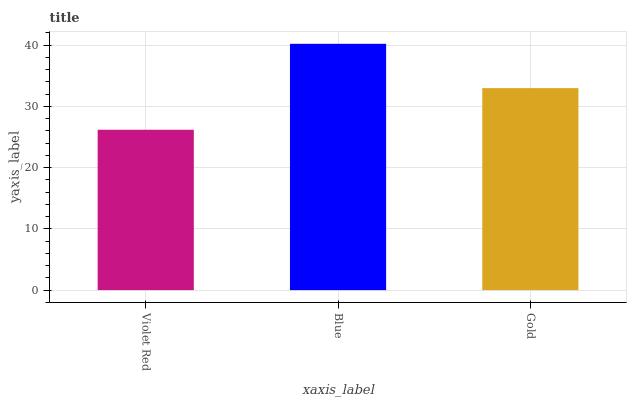Is Violet Red the minimum?
Answer yes or no. Yes. Is Blue the maximum?
Answer yes or no. Yes. Is Gold the minimum?
Answer yes or no. No. Is Gold the maximum?
Answer yes or no. No. Is Blue greater than Gold?
Answer yes or no. Yes. Is Gold less than Blue?
Answer yes or no. Yes. Is Gold greater than Blue?
Answer yes or no. No. Is Blue less than Gold?
Answer yes or no. No. Is Gold the high median?
Answer yes or no. Yes. Is Gold the low median?
Answer yes or no. Yes. Is Blue the high median?
Answer yes or no. No. Is Blue the low median?
Answer yes or no. No. 